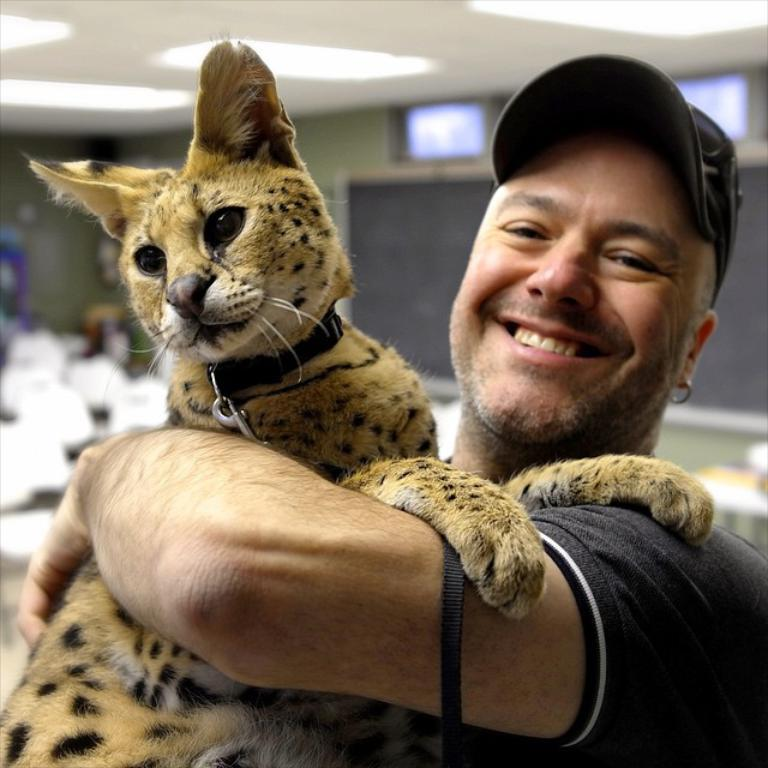Who is present in the image? There is a man in the image. What is the man wearing on his upper body? The man is wearing a grey t-shirt. What type of headwear is the man wearing? The man is wearing a cap. What is the man holding in the image? The man is holding a wild cat. Where was the image taken? The image was taken inside a hall. What can be seen on the ceiling in the image? There are lights on the ceiling in the image. Is the wild cat wearing a collar in the image? There is no mention of a collar on the wild cat in the image. 